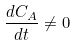<formula> <loc_0><loc_0><loc_500><loc_500>\frac { d C _ { A } } { d t } \ne 0</formula> 